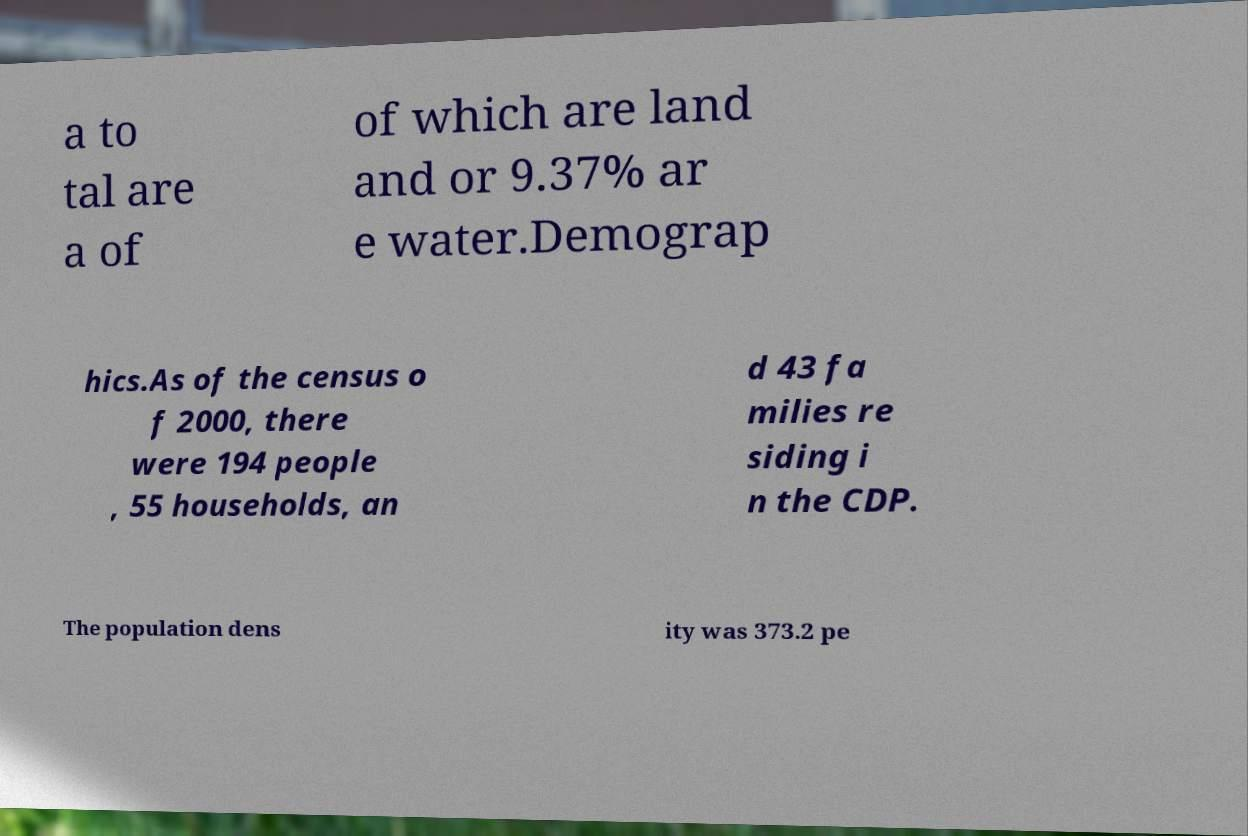There's text embedded in this image that I need extracted. Can you transcribe it verbatim? a to tal are a of of which are land and or 9.37% ar e water.Demograp hics.As of the census o f 2000, there were 194 people , 55 households, an d 43 fa milies re siding i n the CDP. The population dens ity was 373.2 pe 